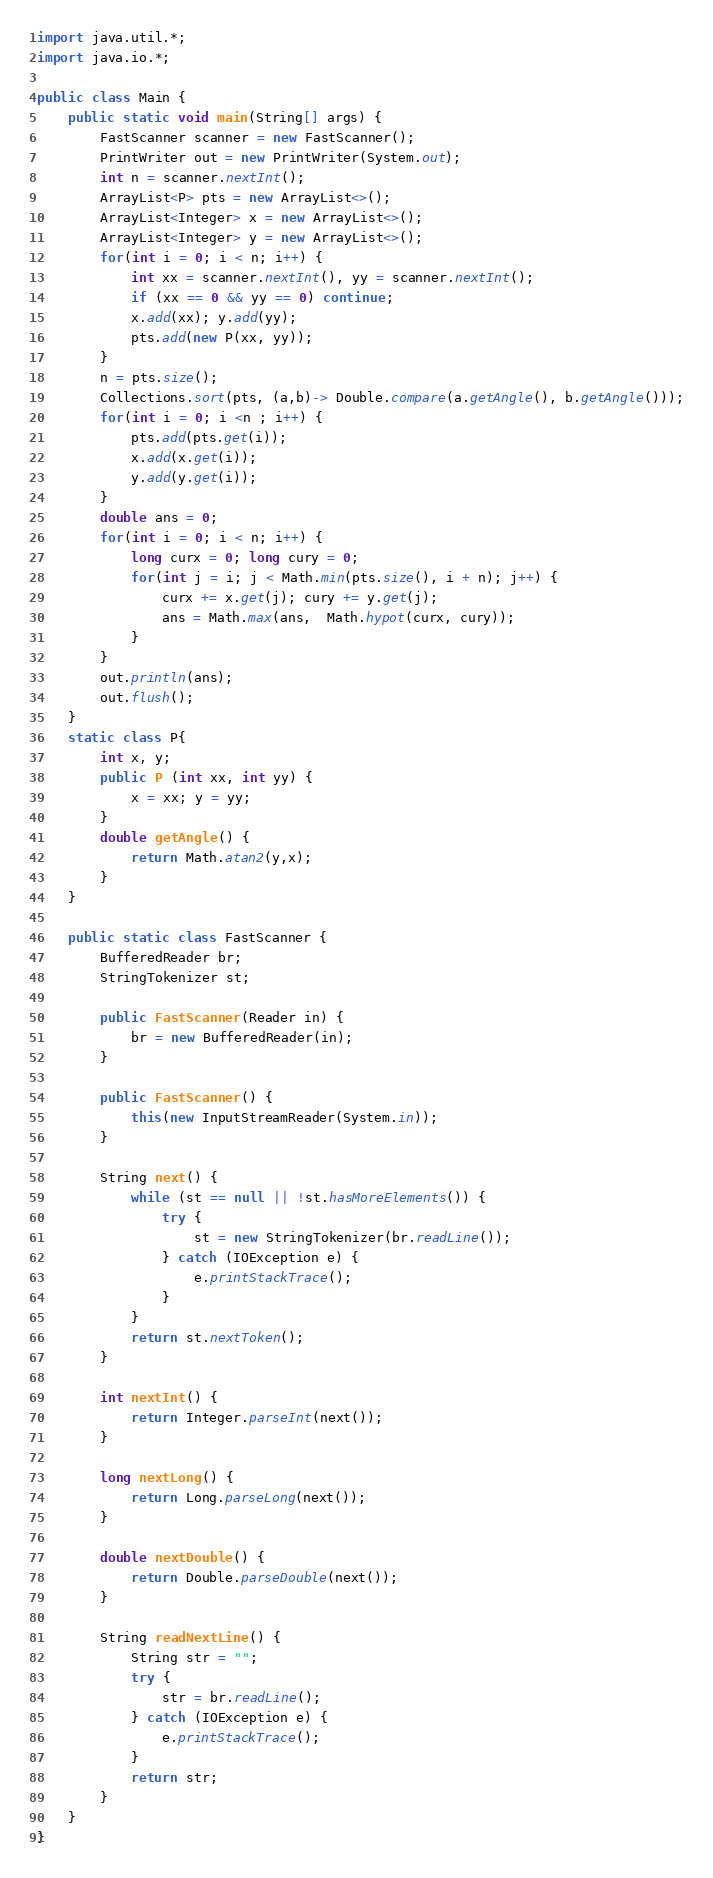<code> <loc_0><loc_0><loc_500><loc_500><_Java_>import java.util.*;
import java.io.*;

public class Main {
    public static void main(String[] args) {
        FastScanner scanner = new FastScanner();
        PrintWriter out = new PrintWriter(System.out);
        int n = scanner.nextInt();
        ArrayList<P> pts = new ArrayList<>();
        ArrayList<Integer> x = new ArrayList<>();
        ArrayList<Integer> y = new ArrayList<>();
        for(int i = 0; i < n; i++) {
            int xx = scanner.nextInt(), yy = scanner.nextInt();
            if (xx == 0 && yy == 0) continue;
            x.add(xx); y.add(yy);
            pts.add(new P(xx, yy));
        }
        n = pts.size();
        Collections.sort(pts, (a,b)-> Double.compare(a.getAngle(), b.getAngle()));
        for(int i = 0; i <n ; i++) {
            pts.add(pts.get(i));
            x.add(x.get(i));
            y.add(y.get(i));
        }
        double ans = 0;
        for(int i = 0; i < n; i++) {
            long curx = 0; long cury = 0;
            for(int j = i; j < Math.min(pts.size(), i + n); j++) {
                curx += x.get(j); cury += y.get(j);
                ans = Math.max(ans,  Math.hypot(curx, cury));
            }
        }
        out.println(ans);
        out.flush();
    }
    static class P{
        int x, y;
        public P (int xx, int yy) {
            x = xx; y = yy;
        }
        double getAngle() {
            return Math.atan2(y,x);
        }
    }
    
    public static class FastScanner {
        BufferedReader br;
        StringTokenizer st;
        
        public FastScanner(Reader in) {
            br = new BufferedReader(in);
        }
        
        public FastScanner() {
            this(new InputStreamReader(System.in));
        }
        
        String next() {
            while (st == null || !st.hasMoreElements()) {
                try {
                    st = new StringTokenizer(br.readLine());
                } catch (IOException e) {
                    e.printStackTrace();
                }
            }
            return st.nextToken();
        }
        
        int nextInt() {
            return Integer.parseInt(next());
        }
        
        long nextLong() {
            return Long.parseLong(next());
        }
        
        double nextDouble() {
            return Double.parseDouble(next());
        }
        
        String readNextLine() {
            String str = "";
            try {
                str = br.readLine();
            } catch (IOException e) {
                e.printStackTrace();
            }
            return str;
        }
    }
}
</code> 